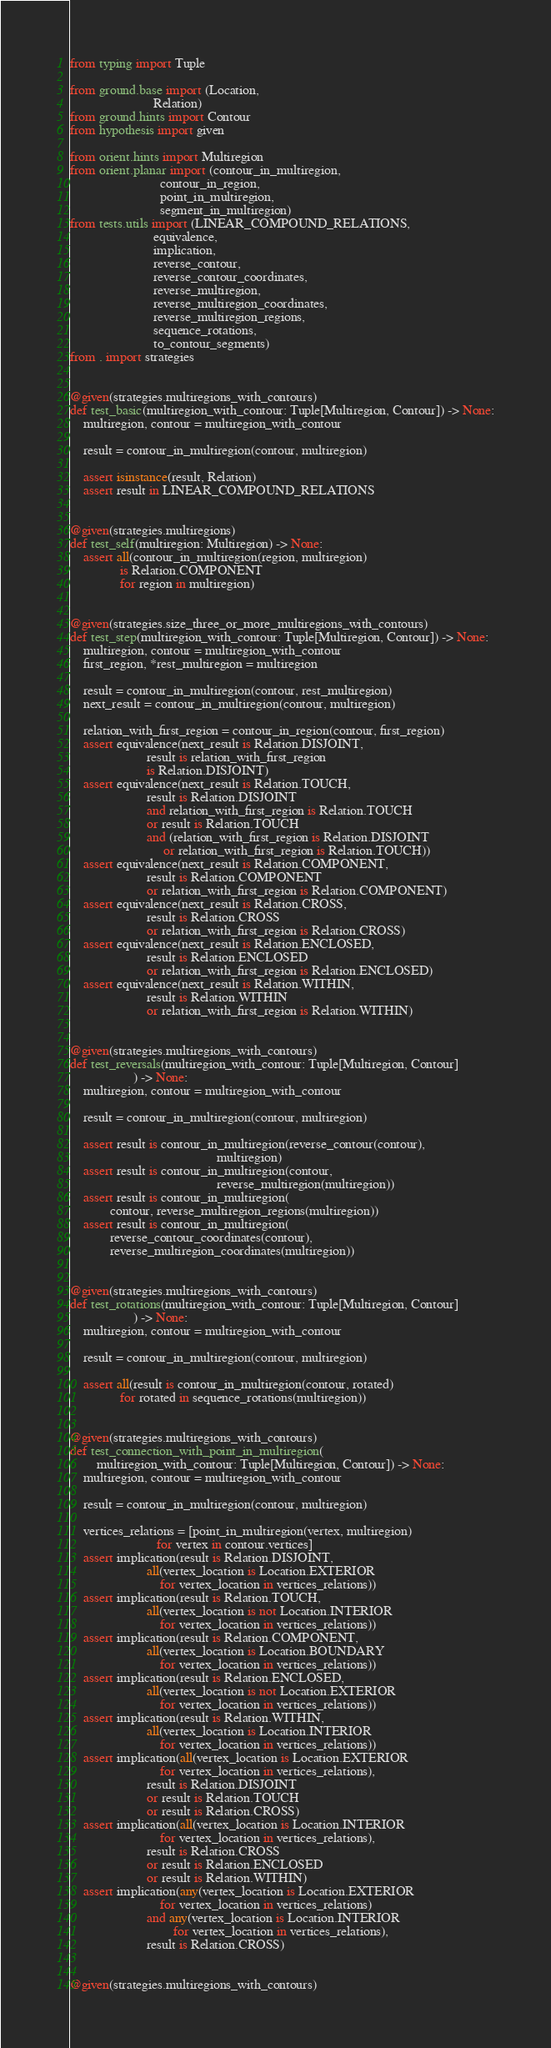Convert code to text. <code><loc_0><loc_0><loc_500><loc_500><_Python_>from typing import Tuple

from ground.base import (Location,
                         Relation)
from ground.hints import Contour
from hypothesis import given

from orient.hints import Multiregion
from orient.planar import (contour_in_multiregion,
                           contour_in_region,
                           point_in_multiregion,
                           segment_in_multiregion)
from tests.utils import (LINEAR_COMPOUND_RELATIONS,
                         equivalence,
                         implication,
                         reverse_contour,
                         reverse_contour_coordinates,
                         reverse_multiregion,
                         reverse_multiregion_coordinates,
                         reverse_multiregion_regions,
                         sequence_rotations,
                         to_contour_segments)
from . import strategies


@given(strategies.multiregions_with_contours)
def test_basic(multiregion_with_contour: Tuple[Multiregion, Contour]) -> None:
    multiregion, contour = multiregion_with_contour

    result = contour_in_multiregion(contour, multiregion)

    assert isinstance(result, Relation)
    assert result in LINEAR_COMPOUND_RELATIONS


@given(strategies.multiregions)
def test_self(multiregion: Multiregion) -> None:
    assert all(contour_in_multiregion(region, multiregion)
               is Relation.COMPONENT
               for region in multiregion)


@given(strategies.size_three_or_more_multiregions_with_contours)
def test_step(multiregion_with_contour: Tuple[Multiregion, Contour]) -> None:
    multiregion, contour = multiregion_with_contour
    first_region, *rest_multiregion = multiregion

    result = contour_in_multiregion(contour, rest_multiregion)
    next_result = contour_in_multiregion(contour, multiregion)

    relation_with_first_region = contour_in_region(contour, first_region)
    assert equivalence(next_result is Relation.DISJOINT,
                       result is relation_with_first_region
                       is Relation.DISJOINT)
    assert equivalence(next_result is Relation.TOUCH,
                       result is Relation.DISJOINT
                       and relation_with_first_region is Relation.TOUCH
                       or result is Relation.TOUCH
                       and (relation_with_first_region is Relation.DISJOINT
                            or relation_with_first_region is Relation.TOUCH))
    assert equivalence(next_result is Relation.COMPONENT,
                       result is Relation.COMPONENT
                       or relation_with_first_region is Relation.COMPONENT)
    assert equivalence(next_result is Relation.CROSS,
                       result is Relation.CROSS
                       or relation_with_first_region is Relation.CROSS)
    assert equivalence(next_result is Relation.ENCLOSED,
                       result is Relation.ENCLOSED
                       or relation_with_first_region is Relation.ENCLOSED)
    assert equivalence(next_result is Relation.WITHIN,
                       result is Relation.WITHIN
                       or relation_with_first_region is Relation.WITHIN)


@given(strategies.multiregions_with_contours)
def test_reversals(multiregion_with_contour: Tuple[Multiregion, Contour]
                   ) -> None:
    multiregion, contour = multiregion_with_contour

    result = contour_in_multiregion(contour, multiregion)

    assert result is contour_in_multiregion(reverse_contour(contour),
                                            multiregion)
    assert result is contour_in_multiregion(contour,
                                            reverse_multiregion(multiregion))
    assert result is contour_in_multiregion(
            contour, reverse_multiregion_regions(multiregion))
    assert result is contour_in_multiregion(
            reverse_contour_coordinates(contour),
            reverse_multiregion_coordinates(multiregion))


@given(strategies.multiregions_with_contours)
def test_rotations(multiregion_with_contour: Tuple[Multiregion, Contour]
                   ) -> None:
    multiregion, contour = multiregion_with_contour

    result = contour_in_multiregion(contour, multiregion)

    assert all(result is contour_in_multiregion(contour, rotated)
               for rotated in sequence_rotations(multiregion))


@given(strategies.multiregions_with_contours)
def test_connection_with_point_in_multiregion(
        multiregion_with_contour: Tuple[Multiregion, Contour]) -> None:
    multiregion, contour = multiregion_with_contour

    result = contour_in_multiregion(contour, multiregion)

    vertices_relations = [point_in_multiregion(vertex, multiregion)
                          for vertex in contour.vertices]
    assert implication(result is Relation.DISJOINT,
                       all(vertex_location is Location.EXTERIOR
                           for vertex_location in vertices_relations))
    assert implication(result is Relation.TOUCH,
                       all(vertex_location is not Location.INTERIOR
                           for vertex_location in vertices_relations))
    assert implication(result is Relation.COMPONENT,
                       all(vertex_location is Location.BOUNDARY
                           for vertex_location in vertices_relations))
    assert implication(result is Relation.ENCLOSED,
                       all(vertex_location is not Location.EXTERIOR
                           for vertex_location in vertices_relations))
    assert implication(result is Relation.WITHIN,
                       all(vertex_location is Location.INTERIOR
                           for vertex_location in vertices_relations))
    assert implication(all(vertex_location is Location.EXTERIOR
                           for vertex_location in vertices_relations),
                       result is Relation.DISJOINT
                       or result is Relation.TOUCH
                       or result is Relation.CROSS)
    assert implication(all(vertex_location is Location.INTERIOR
                           for vertex_location in vertices_relations),
                       result is Relation.CROSS
                       or result is Relation.ENCLOSED
                       or result is Relation.WITHIN)
    assert implication(any(vertex_location is Location.EXTERIOR
                           for vertex_location in vertices_relations)
                       and any(vertex_location is Location.INTERIOR
                               for vertex_location in vertices_relations),
                       result is Relation.CROSS)


@given(strategies.multiregions_with_contours)</code> 